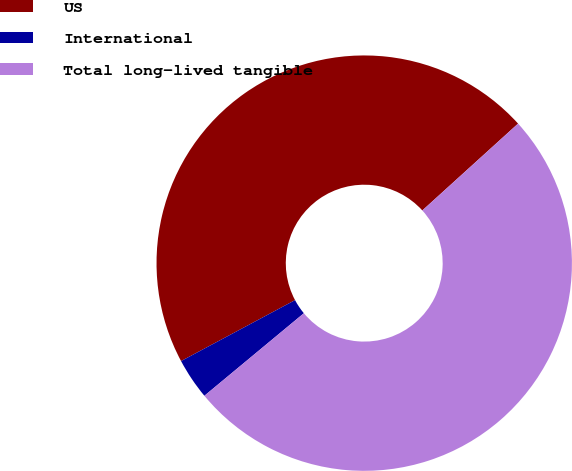<chart> <loc_0><loc_0><loc_500><loc_500><pie_chart><fcel>US<fcel>International<fcel>Total long-lived tangible<nl><fcel>46.09%<fcel>3.21%<fcel>50.7%<nl></chart> 